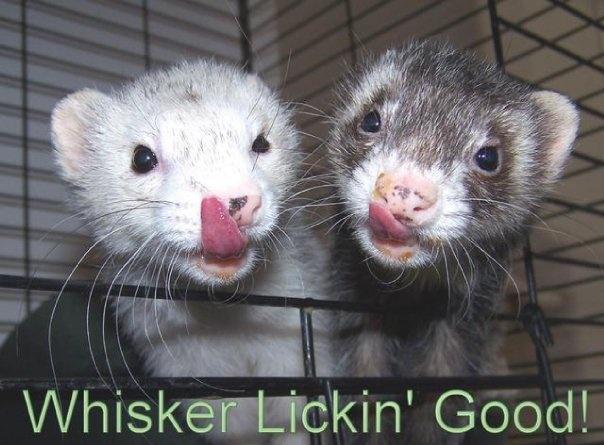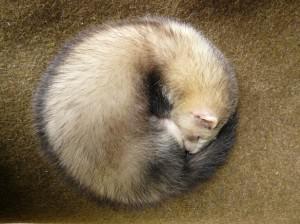The first image is the image on the left, the second image is the image on the right. For the images shown, is this caption "The left image contains two ferrets with their faces close together and their mouths open to some degree." true? Answer yes or no. Yes. The first image is the image on the left, the second image is the image on the right. For the images displayed, is the sentence "The left image contains two ferrets." factually correct? Answer yes or no. Yes. 